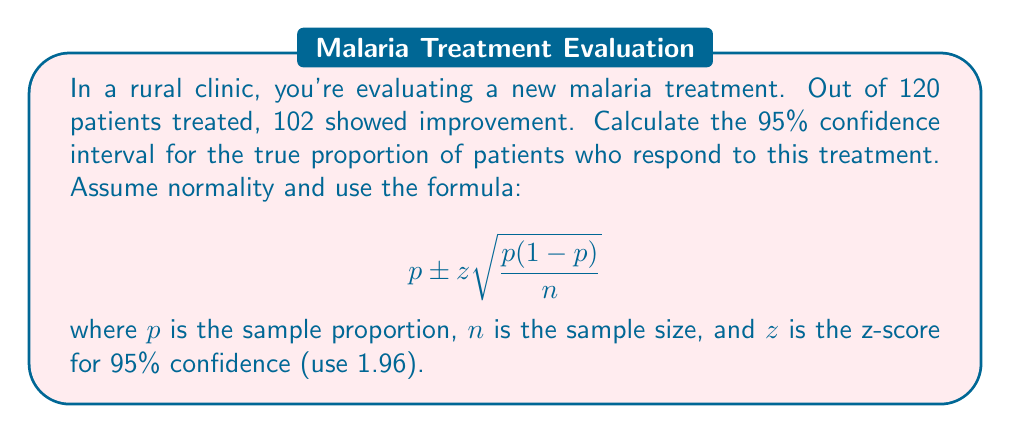Teach me how to tackle this problem. Let's approach this step-by-step:

1) First, calculate the sample proportion $p$:
   $p = \frac{\text{number of successes}}{\text{total sample size}} = \frac{102}{120} = 0.85$

2) We know $n = 120$ and $z = 1.96$ for a 95% confidence interval.

3) Now, let's plug these values into the formula:

   $$ 0.85 \pm 1.96 \sqrt{\frac{0.85(1-0.85)}{120}} $$

4) Simplify inside the square root:
   $$ 0.85 \pm 1.96 \sqrt{\frac{0.85(0.15)}{120}} = 0.85 \pm 1.96 \sqrt{\frac{0.1275}{120}} $$

5) Calculate:
   $$ 0.85 \pm 1.96 \sqrt{0.0010625} = 0.85 \pm 1.96(0.0326) = 0.85 \pm 0.0639 $$

6) Therefore, the confidence interval is:
   $$ (0.85 - 0.0639, 0.85 + 0.0639) = (0.7861, 0.9139) $$

7) Rounding to three decimal places:
   $$ (0.786, 0.914) $$
Answer: (0.786, 0.914) 